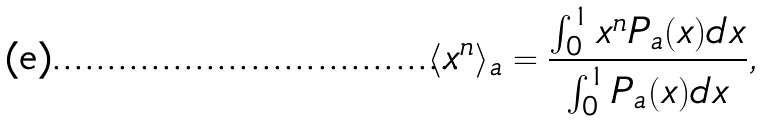<formula> <loc_0><loc_0><loc_500><loc_500>\langle x ^ { n } \rangle _ { a } = \frac { \int _ { 0 } ^ { 1 } x ^ { n } P _ { a } ( x ) d x } { \int _ { 0 } ^ { 1 } P _ { a } ( x ) d x } ,</formula> 